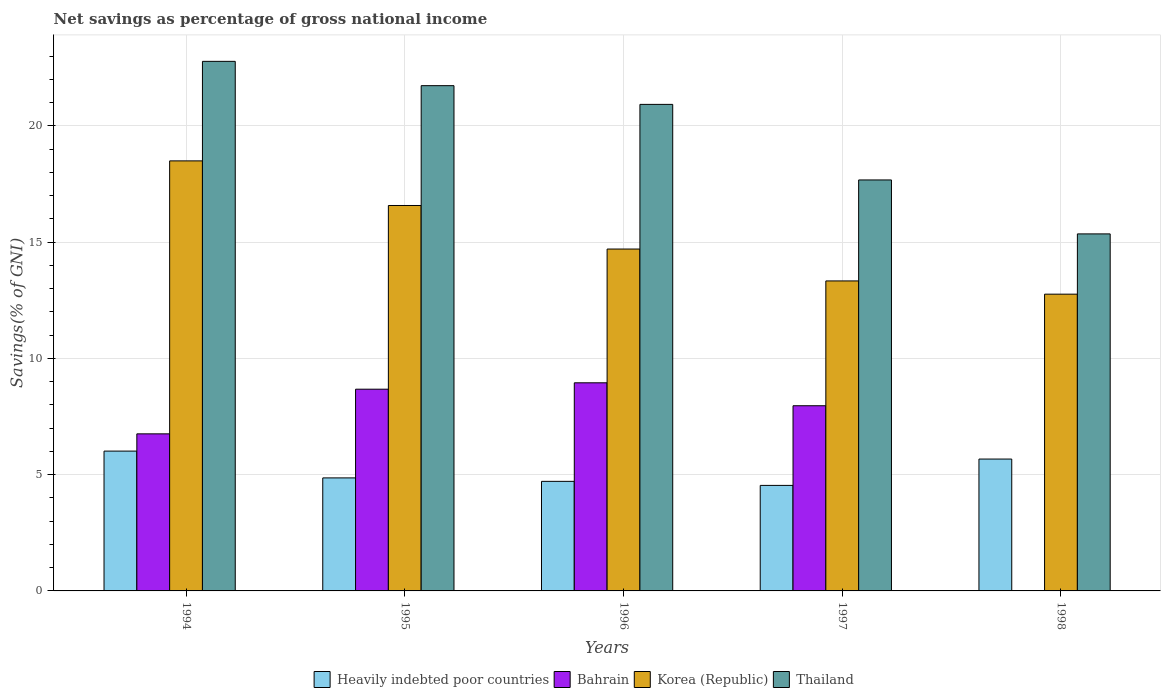How many different coloured bars are there?
Make the answer very short. 4. Are the number of bars per tick equal to the number of legend labels?
Your response must be concise. No. How many bars are there on the 2nd tick from the right?
Your answer should be compact. 4. What is the label of the 2nd group of bars from the left?
Give a very brief answer. 1995. What is the total savings in Korea (Republic) in 1998?
Your answer should be compact. 12.76. Across all years, what is the maximum total savings in Heavily indebted poor countries?
Your answer should be very brief. 6.01. What is the total total savings in Thailand in the graph?
Give a very brief answer. 98.46. What is the difference between the total savings in Thailand in 1994 and that in 1996?
Offer a very short reply. 1.85. What is the difference between the total savings in Bahrain in 1998 and the total savings in Heavily indebted poor countries in 1995?
Offer a terse response. -4.86. What is the average total savings in Bahrain per year?
Your answer should be compact. 6.47. In the year 1998, what is the difference between the total savings in Korea (Republic) and total savings in Thailand?
Offer a very short reply. -2.59. What is the ratio of the total savings in Heavily indebted poor countries in 1997 to that in 1998?
Make the answer very short. 0.8. Is the total savings in Thailand in 1997 less than that in 1998?
Provide a succinct answer. No. Is the difference between the total savings in Korea (Republic) in 1994 and 1996 greater than the difference between the total savings in Thailand in 1994 and 1996?
Offer a terse response. Yes. What is the difference between the highest and the second highest total savings in Heavily indebted poor countries?
Give a very brief answer. 0.34. What is the difference between the highest and the lowest total savings in Bahrain?
Keep it short and to the point. 8.95. Is the sum of the total savings in Thailand in 1994 and 1996 greater than the maximum total savings in Heavily indebted poor countries across all years?
Your response must be concise. Yes. How many bars are there?
Your response must be concise. 19. How many years are there in the graph?
Offer a very short reply. 5. What is the difference between two consecutive major ticks on the Y-axis?
Give a very brief answer. 5. Does the graph contain any zero values?
Give a very brief answer. Yes. How many legend labels are there?
Offer a very short reply. 4. How are the legend labels stacked?
Your response must be concise. Horizontal. What is the title of the graph?
Ensure brevity in your answer.  Net savings as percentage of gross national income. What is the label or title of the Y-axis?
Make the answer very short. Savings(% of GNI). What is the Savings(% of GNI) of Heavily indebted poor countries in 1994?
Provide a short and direct response. 6.01. What is the Savings(% of GNI) of Bahrain in 1994?
Provide a short and direct response. 6.76. What is the Savings(% of GNI) of Korea (Republic) in 1994?
Your response must be concise. 18.5. What is the Savings(% of GNI) of Thailand in 1994?
Make the answer very short. 22.78. What is the Savings(% of GNI) of Heavily indebted poor countries in 1995?
Keep it short and to the point. 4.86. What is the Savings(% of GNI) in Bahrain in 1995?
Provide a succinct answer. 8.68. What is the Savings(% of GNI) of Korea (Republic) in 1995?
Make the answer very short. 16.58. What is the Savings(% of GNI) in Thailand in 1995?
Keep it short and to the point. 21.73. What is the Savings(% of GNI) in Heavily indebted poor countries in 1996?
Give a very brief answer. 4.71. What is the Savings(% of GNI) in Bahrain in 1996?
Your answer should be very brief. 8.95. What is the Savings(% of GNI) of Korea (Republic) in 1996?
Your response must be concise. 14.7. What is the Savings(% of GNI) of Thailand in 1996?
Provide a succinct answer. 20.93. What is the Savings(% of GNI) of Heavily indebted poor countries in 1997?
Keep it short and to the point. 4.54. What is the Savings(% of GNI) in Bahrain in 1997?
Keep it short and to the point. 7.96. What is the Savings(% of GNI) in Korea (Republic) in 1997?
Provide a succinct answer. 13.33. What is the Savings(% of GNI) of Thailand in 1997?
Offer a terse response. 17.68. What is the Savings(% of GNI) of Heavily indebted poor countries in 1998?
Make the answer very short. 5.67. What is the Savings(% of GNI) of Bahrain in 1998?
Keep it short and to the point. 0. What is the Savings(% of GNI) in Korea (Republic) in 1998?
Ensure brevity in your answer.  12.76. What is the Savings(% of GNI) in Thailand in 1998?
Your answer should be compact. 15.36. Across all years, what is the maximum Savings(% of GNI) of Heavily indebted poor countries?
Ensure brevity in your answer.  6.01. Across all years, what is the maximum Savings(% of GNI) of Bahrain?
Provide a short and direct response. 8.95. Across all years, what is the maximum Savings(% of GNI) in Korea (Republic)?
Give a very brief answer. 18.5. Across all years, what is the maximum Savings(% of GNI) in Thailand?
Give a very brief answer. 22.78. Across all years, what is the minimum Savings(% of GNI) of Heavily indebted poor countries?
Give a very brief answer. 4.54. Across all years, what is the minimum Savings(% of GNI) in Korea (Republic)?
Make the answer very short. 12.76. Across all years, what is the minimum Savings(% of GNI) of Thailand?
Offer a terse response. 15.36. What is the total Savings(% of GNI) of Heavily indebted poor countries in the graph?
Offer a terse response. 25.8. What is the total Savings(% of GNI) of Bahrain in the graph?
Keep it short and to the point. 32.35. What is the total Savings(% of GNI) in Korea (Republic) in the graph?
Keep it short and to the point. 75.87. What is the total Savings(% of GNI) of Thailand in the graph?
Make the answer very short. 98.46. What is the difference between the Savings(% of GNI) of Heavily indebted poor countries in 1994 and that in 1995?
Ensure brevity in your answer.  1.15. What is the difference between the Savings(% of GNI) of Bahrain in 1994 and that in 1995?
Keep it short and to the point. -1.92. What is the difference between the Savings(% of GNI) in Korea (Republic) in 1994 and that in 1995?
Ensure brevity in your answer.  1.92. What is the difference between the Savings(% of GNI) in Thailand in 1994 and that in 1995?
Give a very brief answer. 1.05. What is the difference between the Savings(% of GNI) of Heavily indebted poor countries in 1994 and that in 1996?
Provide a succinct answer. 1.3. What is the difference between the Savings(% of GNI) of Bahrain in 1994 and that in 1996?
Give a very brief answer. -2.2. What is the difference between the Savings(% of GNI) of Korea (Republic) in 1994 and that in 1996?
Your response must be concise. 3.79. What is the difference between the Savings(% of GNI) in Thailand in 1994 and that in 1996?
Make the answer very short. 1.85. What is the difference between the Savings(% of GNI) of Heavily indebted poor countries in 1994 and that in 1997?
Offer a terse response. 1.48. What is the difference between the Savings(% of GNI) of Bahrain in 1994 and that in 1997?
Offer a terse response. -1.21. What is the difference between the Savings(% of GNI) in Korea (Republic) in 1994 and that in 1997?
Ensure brevity in your answer.  5.16. What is the difference between the Savings(% of GNI) in Thailand in 1994 and that in 1997?
Keep it short and to the point. 5.1. What is the difference between the Savings(% of GNI) in Heavily indebted poor countries in 1994 and that in 1998?
Keep it short and to the point. 0.34. What is the difference between the Savings(% of GNI) in Korea (Republic) in 1994 and that in 1998?
Your answer should be compact. 5.73. What is the difference between the Savings(% of GNI) of Thailand in 1994 and that in 1998?
Offer a terse response. 7.42. What is the difference between the Savings(% of GNI) of Heavily indebted poor countries in 1995 and that in 1996?
Your response must be concise. 0.15. What is the difference between the Savings(% of GNI) in Bahrain in 1995 and that in 1996?
Keep it short and to the point. -0.27. What is the difference between the Savings(% of GNI) of Korea (Republic) in 1995 and that in 1996?
Provide a succinct answer. 1.87. What is the difference between the Savings(% of GNI) of Thailand in 1995 and that in 1996?
Your response must be concise. 0.8. What is the difference between the Savings(% of GNI) of Heavily indebted poor countries in 1995 and that in 1997?
Ensure brevity in your answer.  0.32. What is the difference between the Savings(% of GNI) of Bahrain in 1995 and that in 1997?
Ensure brevity in your answer.  0.71. What is the difference between the Savings(% of GNI) in Korea (Republic) in 1995 and that in 1997?
Your answer should be very brief. 3.24. What is the difference between the Savings(% of GNI) in Thailand in 1995 and that in 1997?
Your answer should be very brief. 4.05. What is the difference between the Savings(% of GNI) in Heavily indebted poor countries in 1995 and that in 1998?
Give a very brief answer. -0.81. What is the difference between the Savings(% of GNI) in Korea (Republic) in 1995 and that in 1998?
Offer a very short reply. 3.81. What is the difference between the Savings(% of GNI) of Thailand in 1995 and that in 1998?
Keep it short and to the point. 6.38. What is the difference between the Savings(% of GNI) in Heavily indebted poor countries in 1996 and that in 1997?
Your response must be concise. 0.17. What is the difference between the Savings(% of GNI) in Bahrain in 1996 and that in 1997?
Your answer should be very brief. 0.99. What is the difference between the Savings(% of GNI) in Korea (Republic) in 1996 and that in 1997?
Give a very brief answer. 1.37. What is the difference between the Savings(% of GNI) in Thailand in 1996 and that in 1997?
Make the answer very short. 3.25. What is the difference between the Savings(% of GNI) of Heavily indebted poor countries in 1996 and that in 1998?
Offer a terse response. -0.96. What is the difference between the Savings(% of GNI) of Korea (Republic) in 1996 and that in 1998?
Keep it short and to the point. 1.94. What is the difference between the Savings(% of GNI) in Thailand in 1996 and that in 1998?
Offer a terse response. 5.57. What is the difference between the Savings(% of GNI) of Heavily indebted poor countries in 1997 and that in 1998?
Offer a very short reply. -1.13. What is the difference between the Savings(% of GNI) of Korea (Republic) in 1997 and that in 1998?
Provide a short and direct response. 0.57. What is the difference between the Savings(% of GNI) of Thailand in 1997 and that in 1998?
Your answer should be compact. 2.32. What is the difference between the Savings(% of GNI) in Heavily indebted poor countries in 1994 and the Savings(% of GNI) in Bahrain in 1995?
Provide a short and direct response. -2.66. What is the difference between the Savings(% of GNI) in Heavily indebted poor countries in 1994 and the Savings(% of GNI) in Korea (Republic) in 1995?
Ensure brevity in your answer.  -10.56. What is the difference between the Savings(% of GNI) of Heavily indebted poor countries in 1994 and the Savings(% of GNI) of Thailand in 1995?
Provide a short and direct response. -15.72. What is the difference between the Savings(% of GNI) of Bahrain in 1994 and the Savings(% of GNI) of Korea (Republic) in 1995?
Your response must be concise. -9.82. What is the difference between the Savings(% of GNI) in Bahrain in 1994 and the Savings(% of GNI) in Thailand in 1995?
Your answer should be compact. -14.98. What is the difference between the Savings(% of GNI) of Korea (Republic) in 1994 and the Savings(% of GNI) of Thailand in 1995?
Keep it short and to the point. -3.23. What is the difference between the Savings(% of GNI) in Heavily indebted poor countries in 1994 and the Savings(% of GNI) in Bahrain in 1996?
Offer a very short reply. -2.94. What is the difference between the Savings(% of GNI) in Heavily indebted poor countries in 1994 and the Savings(% of GNI) in Korea (Republic) in 1996?
Your answer should be compact. -8.69. What is the difference between the Savings(% of GNI) of Heavily indebted poor countries in 1994 and the Savings(% of GNI) of Thailand in 1996?
Ensure brevity in your answer.  -14.91. What is the difference between the Savings(% of GNI) in Bahrain in 1994 and the Savings(% of GNI) in Korea (Republic) in 1996?
Offer a terse response. -7.95. What is the difference between the Savings(% of GNI) in Bahrain in 1994 and the Savings(% of GNI) in Thailand in 1996?
Your response must be concise. -14.17. What is the difference between the Savings(% of GNI) of Korea (Republic) in 1994 and the Savings(% of GNI) of Thailand in 1996?
Give a very brief answer. -2.43. What is the difference between the Savings(% of GNI) of Heavily indebted poor countries in 1994 and the Savings(% of GNI) of Bahrain in 1997?
Offer a very short reply. -1.95. What is the difference between the Savings(% of GNI) in Heavily indebted poor countries in 1994 and the Savings(% of GNI) in Korea (Republic) in 1997?
Your response must be concise. -7.32. What is the difference between the Savings(% of GNI) in Heavily indebted poor countries in 1994 and the Savings(% of GNI) in Thailand in 1997?
Make the answer very short. -11.66. What is the difference between the Savings(% of GNI) of Bahrain in 1994 and the Savings(% of GNI) of Korea (Republic) in 1997?
Make the answer very short. -6.58. What is the difference between the Savings(% of GNI) in Bahrain in 1994 and the Savings(% of GNI) in Thailand in 1997?
Provide a short and direct response. -10.92. What is the difference between the Savings(% of GNI) of Korea (Republic) in 1994 and the Savings(% of GNI) of Thailand in 1997?
Your response must be concise. 0.82. What is the difference between the Savings(% of GNI) in Heavily indebted poor countries in 1994 and the Savings(% of GNI) in Korea (Republic) in 1998?
Make the answer very short. -6.75. What is the difference between the Savings(% of GNI) in Heavily indebted poor countries in 1994 and the Savings(% of GNI) in Thailand in 1998?
Ensure brevity in your answer.  -9.34. What is the difference between the Savings(% of GNI) of Bahrain in 1994 and the Savings(% of GNI) of Korea (Republic) in 1998?
Offer a very short reply. -6.01. What is the difference between the Savings(% of GNI) of Bahrain in 1994 and the Savings(% of GNI) of Thailand in 1998?
Provide a short and direct response. -8.6. What is the difference between the Savings(% of GNI) of Korea (Republic) in 1994 and the Savings(% of GNI) of Thailand in 1998?
Offer a very short reply. 3.14. What is the difference between the Savings(% of GNI) of Heavily indebted poor countries in 1995 and the Savings(% of GNI) of Bahrain in 1996?
Ensure brevity in your answer.  -4.09. What is the difference between the Savings(% of GNI) of Heavily indebted poor countries in 1995 and the Savings(% of GNI) of Korea (Republic) in 1996?
Your answer should be compact. -9.84. What is the difference between the Savings(% of GNI) in Heavily indebted poor countries in 1995 and the Savings(% of GNI) in Thailand in 1996?
Your response must be concise. -16.06. What is the difference between the Savings(% of GNI) of Bahrain in 1995 and the Savings(% of GNI) of Korea (Republic) in 1996?
Make the answer very short. -6.03. What is the difference between the Savings(% of GNI) of Bahrain in 1995 and the Savings(% of GNI) of Thailand in 1996?
Your answer should be very brief. -12.25. What is the difference between the Savings(% of GNI) in Korea (Republic) in 1995 and the Savings(% of GNI) in Thailand in 1996?
Provide a succinct answer. -4.35. What is the difference between the Savings(% of GNI) in Heavily indebted poor countries in 1995 and the Savings(% of GNI) in Bahrain in 1997?
Your answer should be compact. -3.1. What is the difference between the Savings(% of GNI) in Heavily indebted poor countries in 1995 and the Savings(% of GNI) in Korea (Republic) in 1997?
Keep it short and to the point. -8.47. What is the difference between the Savings(% of GNI) in Heavily indebted poor countries in 1995 and the Savings(% of GNI) in Thailand in 1997?
Ensure brevity in your answer.  -12.82. What is the difference between the Savings(% of GNI) in Bahrain in 1995 and the Savings(% of GNI) in Korea (Republic) in 1997?
Your response must be concise. -4.66. What is the difference between the Savings(% of GNI) in Bahrain in 1995 and the Savings(% of GNI) in Thailand in 1997?
Offer a terse response. -9. What is the difference between the Savings(% of GNI) in Korea (Republic) in 1995 and the Savings(% of GNI) in Thailand in 1997?
Your answer should be compact. -1.1. What is the difference between the Savings(% of GNI) of Heavily indebted poor countries in 1995 and the Savings(% of GNI) of Korea (Republic) in 1998?
Offer a terse response. -7.9. What is the difference between the Savings(% of GNI) in Heavily indebted poor countries in 1995 and the Savings(% of GNI) in Thailand in 1998?
Provide a short and direct response. -10.49. What is the difference between the Savings(% of GNI) of Bahrain in 1995 and the Savings(% of GNI) of Korea (Republic) in 1998?
Your answer should be compact. -4.09. What is the difference between the Savings(% of GNI) in Bahrain in 1995 and the Savings(% of GNI) in Thailand in 1998?
Your response must be concise. -6.68. What is the difference between the Savings(% of GNI) of Korea (Republic) in 1995 and the Savings(% of GNI) of Thailand in 1998?
Keep it short and to the point. 1.22. What is the difference between the Savings(% of GNI) in Heavily indebted poor countries in 1996 and the Savings(% of GNI) in Bahrain in 1997?
Provide a short and direct response. -3.25. What is the difference between the Savings(% of GNI) of Heavily indebted poor countries in 1996 and the Savings(% of GNI) of Korea (Republic) in 1997?
Keep it short and to the point. -8.62. What is the difference between the Savings(% of GNI) in Heavily indebted poor countries in 1996 and the Savings(% of GNI) in Thailand in 1997?
Your response must be concise. -12.96. What is the difference between the Savings(% of GNI) in Bahrain in 1996 and the Savings(% of GNI) in Korea (Republic) in 1997?
Provide a succinct answer. -4.38. What is the difference between the Savings(% of GNI) of Bahrain in 1996 and the Savings(% of GNI) of Thailand in 1997?
Offer a very short reply. -8.73. What is the difference between the Savings(% of GNI) of Korea (Republic) in 1996 and the Savings(% of GNI) of Thailand in 1997?
Provide a short and direct response. -2.97. What is the difference between the Savings(% of GNI) in Heavily indebted poor countries in 1996 and the Savings(% of GNI) in Korea (Republic) in 1998?
Give a very brief answer. -8.05. What is the difference between the Savings(% of GNI) in Heavily indebted poor countries in 1996 and the Savings(% of GNI) in Thailand in 1998?
Your answer should be very brief. -10.64. What is the difference between the Savings(% of GNI) of Bahrain in 1996 and the Savings(% of GNI) of Korea (Republic) in 1998?
Ensure brevity in your answer.  -3.81. What is the difference between the Savings(% of GNI) of Bahrain in 1996 and the Savings(% of GNI) of Thailand in 1998?
Your answer should be very brief. -6.4. What is the difference between the Savings(% of GNI) of Korea (Republic) in 1996 and the Savings(% of GNI) of Thailand in 1998?
Your response must be concise. -0.65. What is the difference between the Savings(% of GNI) in Heavily indebted poor countries in 1997 and the Savings(% of GNI) in Korea (Republic) in 1998?
Provide a short and direct response. -8.22. What is the difference between the Savings(% of GNI) of Heavily indebted poor countries in 1997 and the Savings(% of GNI) of Thailand in 1998?
Give a very brief answer. -10.82. What is the difference between the Savings(% of GNI) in Bahrain in 1997 and the Savings(% of GNI) in Korea (Republic) in 1998?
Make the answer very short. -4.8. What is the difference between the Savings(% of GNI) of Bahrain in 1997 and the Savings(% of GNI) of Thailand in 1998?
Keep it short and to the point. -7.39. What is the difference between the Savings(% of GNI) in Korea (Republic) in 1997 and the Savings(% of GNI) in Thailand in 1998?
Your answer should be compact. -2.02. What is the average Savings(% of GNI) in Heavily indebted poor countries per year?
Offer a very short reply. 5.16. What is the average Savings(% of GNI) in Bahrain per year?
Ensure brevity in your answer.  6.47. What is the average Savings(% of GNI) in Korea (Republic) per year?
Provide a short and direct response. 15.17. What is the average Savings(% of GNI) in Thailand per year?
Keep it short and to the point. 19.69. In the year 1994, what is the difference between the Savings(% of GNI) of Heavily indebted poor countries and Savings(% of GNI) of Bahrain?
Keep it short and to the point. -0.74. In the year 1994, what is the difference between the Savings(% of GNI) in Heavily indebted poor countries and Savings(% of GNI) in Korea (Republic)?
Provide a short and direct response. -12.48. In the year 1994, what is the difference between the Savings(% of GNI) in Heavily indebted poor countries and Savings(% of GNI) in Thailand?
Keep it short and to the point. -16.76. In the year 1994, what is the difference between the Savings(% of GNI) in Bahrain and Savings(% of GNI) in Korea (Republic)?
Your answer should be very brief. -11.74. In the year 1994, what is the difference between the Savings(% of GNI) of Bahrain and Savings(% of GNI) of Thailand?
Offer a very short reply. -16.02. In the year 1994, what is the difference between the Savings(% of GNI) of Korea (Republic) and Savings(% of GNI) of Thailand?
Offer a very short reply. -4.28. In the year 1995, what is the difference between the Savings(% of GNI) in Heavily indebted poor countries and Savings(% of GNI) in Bahrain?
Provide a succinct answer. -3.81. In the year 1995, what is the difference between the Savings(% of GNI) in Heavily indebted poor countries and Savings(% of GNI) in Korea (Republic)?
Offer a very short reply. -11.72. In the year 1995, what is the difference between the Savings(% of GNI) in Heavily indebted poor countries and Savings(% of GNI) in Thailand?
Your answer should be very brief. -16.87. In the year 1995, what is the difference between the Savings(% of GNI) in Bahrain and Savings(% of GNI) in Korea (Republic)?
Your response must be concise. -7.9. In the year 1995, what is the difference between the Savings(% of GNI) of Bahrain and Savings(% of GNI) of Thailand?
Offer a terse response. -13.05. In the year 1995, what is the difference between the Savings(% of GNI) of Korea (Republic) and Savings(% of GNI) of Thailand?
Offer a very short reply. -5.15. In the year 1996, what is the difference between the Savings(% of GNI) of Heavily indebted poor countries and Savings(% of GNI) of Bahrain?
Provide a succinct answer. -4.24. In the year 1996, what is the difference between the Savings(% of GNI) of Heavily indebted poor countries and Savings(% of GNI) of Korea (Republic)?
Make the answer very short. -9.99. In the year 1996, what is the difference between the Savings(% of GNI) in Heavily indebted poor countries and Savings(% of GNI) in Thailand?
Your answer should be compact. -16.21. In the year 1996, what is the difference between the Savings(% of GNI) of Bahrain and Savings(% of GNI) of Korea (Republic)?
Make the answer very short. -5.75. In the year 1996, what is the difference between the Savings(% of GNI) of Bahrain and Savings(% of GNI) of Thailand?
Give a very brief answer. -11.97. In the year 1996, what is the difference between the Savings(% of GNI) of Korea (Republic) and Savings(% of GNI) of Thailand?
Your answer should be compact. -6.22. In the year 1997, what is the difference between the Savings(% of GNI) in Heavily indebted poor countries and Savings(% of GNI) in Bahrain?
Offer a terse response. -3.43. In the year 1997, what is the difference between the Savings(% of GNI) of Heavily indebted poor countries and Savings(% of GNI) of Korea (Republic)?
Your answer should be compact. -8.79. In the year 1997, what is the difference between the Savings(% of GNI) of Heavily indebted poor countries and Savings(% of GNI) of Thailand?
Provide a succinct answer. -13.14. In the year 1997, what is the difference between the Savings(% of GNI) in Bahrain and Savings(% of GNI) in Korea (Republic)?
Your answer should be compact. -5.37. In the year 1997, what is the difference between the Savings(% of GNI) in Bahrain and Savings(% of GNI) in Thailand?
Your answer should be very brief. -9.71. In the year 1997, what is the difference between the Savings(% of GNI) in Korea (Republic) and Savings(% of GNI) in Thailand?
Keep it short and to the point. -4.34. In the year 1998, what is the difference between the Savings(% of GNI) in Heavily indebted poor countries and Savings(% of GNI) in Korea (Republic)?
Make the answer very short. -7.09. In the year 1998, what is the difference between the Savings(% of GNI) in Heavily indebted poor countries and Savings(% of GNI) in Thailand?
Keep it short and to the point. -9.68. In the year 1998, what is the difference between the Savings(% of GNI) of Korea (Republic) and Savings(% of GNI) of Thailand?
Give a very brief answer. -2.59. What is the ratio of the Savings(% of GNI) of Heavily indebted poor countries in 1994 to that in 1995?
Give a very brief answer. 1.24. What is the ratio of the Savings(% of GNI) in Bahrain in 1994 to that in 1995?
Your answer should be compact. 0.78. What is the ratio of the Savings(% of GNI) in Korea (Republic) in 1994 to that in 1995?
Offer a terse response. 1.12. What is the ratio of the Savings(% of GNI) of Thailand in 1994 to that in 1995?
Provide a succinct answer. 1.05. What is the ratio of the Savings(% of GNI) of Heavily indebted poor countries in 1994 to that in 1996?
Ensure brevity in your answer.  1.28. What is the ratio of the Savings(% of GNI) of Bahrain in 1994 to that in 1996?
Give a very brief answer. 0.75. What is the ratio of the Savings(% of GNI) of Korea (Republic) in 1994 to that in 1996?
Your answer should be very brief. 1.26. What is the ratio of the Savings(% of GNI) of Thailand in 1994 to that in 1996?
Your answer should be very brief. 1.09. What is the ratio of the Savings(% of GNI) in Heavily indebted poor countries in 1994 to that in 1997?
Provide a succinct answer. 1.32. What is the ratio of the Savings(% of GNI) in Bahrain in 1994 to that in 1997?
Offer a terse response. 0.85. What is the ratio of the Savings(% of GNI) of Korea (Republic) in 1994 to that in 1997?
Offer a terse response. 1.39. What is the ratio of the Savings(% of GNI) in Thailand in 1994 to that in 1997?
Provide a succinct answer. 1.29. What is the ratio of the Savings(% of GNI) of Heavily indebted poor countries in 1994 to that in 1998?
Offer a terse response. 1.06. What is the ratio of the Savings(% of GNI) of Korea (Republic) in 1994 to that in 1998?
Provide a succinct answer. 1.45. What is the ratio of the Savings(% of GNI) in Thailand in 1994 to that in 1998?
Provide a short and direct response. 1.48. What is the ratio of the Savings(% of GNI) of Heavily indebted poor countries in 1995 to that in 1996?
Your response must be concise. 1.03. What is the ratio of the Savings(% of GNI) in Bahrain in 1995 to that in 1996?
Keep it short and to the point. 0.97. What is the ratio of the Savings(% of GNI) of Korea (Republic) in 1995 to that in 1996?
Keep it short and to the point. 1.13. What is the ratio of the Savings(% of GNI) in Heavily indebted poor countries in 1995 to that in 1997?
Your response must be concise. 1.07. What is the ratio of the Savings(% of GNI) of Bahrain in 1995 to that in 1997?
Your answer should be very brief. 1.09. What is the ratio of the Savings(% of GNI) of Korea (Republic) in 1995 to that in 1997?
Offer a very short reply. 1.24. What is the ratio of the Savings(% of GNI) in Thailand in 1995 to that in 1997?
Your answer should be very brief. 1.23. What is the ratio of the Savings(% of GNI) of Korea (Republic) in 1995 to that in 1998?
Keep it short and to the point. 1.3. What is the ratio of the Savings(% of GNI) of Thailand in 1995 to that in 1998?
Your answer should be very brief. 1.42. What is the ratio of the Savings(% of GNI) in Heavily indebted poor countries in 1996 to that in 1997?
Keep it short and to the point. 1.04. What is the ratio of the Savings(% of GNI) in Bahrain in 1996 to that in 1997?
Make the answer very short. 1.12. What is the ratio of the Savings(% of GNI) of Korea (Republic) in 1996 to that in 1997?
Your answer should be compact. 1.1. What is the ratio of the Savings(% of GNI) of Thailand in 1996 to that in 1997?
Keep it short and to the point. 1.18. What is the ratio of the Savings(% of GNI) of Heavily indebted poor countries in 1996 to that in 1998?
Provide a short and direct response. 0.83. What is the ratio of the Savings(% of GNI) of Korea (Republic) in 1996 to that in 1998?
Your answer should be compact. 1.15. What is the ratio of the Savings(% of GNI) of Thailand in 1996 to that in 1998?
Give a very brief answer. 1.36. What is the ratio of the Savings(% of GNI) of Heavily indebted poor countries in 1997 to that in 1998?
Your response must be concise. 0.8. What is the ratio of the Savings(% of GNI) of Korea (Republic) in 1997 to that in 1998?
Give a very brief answer. 1.04. What is the ratio of the Savings(% of GNI) of Thailand in 1997 to that in 1998?
Your answer should be compact. 1.15. What is the difference between the highest and the second highest Savings(% of GNI) in Heavily indebted poor countries?
Offer a terse response. 0.34. What is the difference between the highest and the second highest Savings(% of GNI) in Bahrain?
Your answer should be very brief. 0.27. What is the difference between the highest and the second highest Savings(% of GNI) in Korea (Republic)?
Keep it short and to the point. 1.92. What is the difference between the highest and the second highest Savings(% of GNI) of Thailand?
Make the answer very short. 1.05. What is the difference between the highest and the lowest Savings(% of GNI) in Heavily indebted poor countries?
Your response must be concise. 1.48. What is the difference between the highest and the lowest Savings(% of GNI) in Bahrain?
Provide a succinct answer. 8.95. What is the difference between the highest and the lowest Savings(% of GNI) of Korea (Republic)?
Ensure brevity in your answer.  5.73. What is the difference between the highest and the lowest Savings(% of GNI) of Thailand?
Provide a succinct answer. 7.42. 